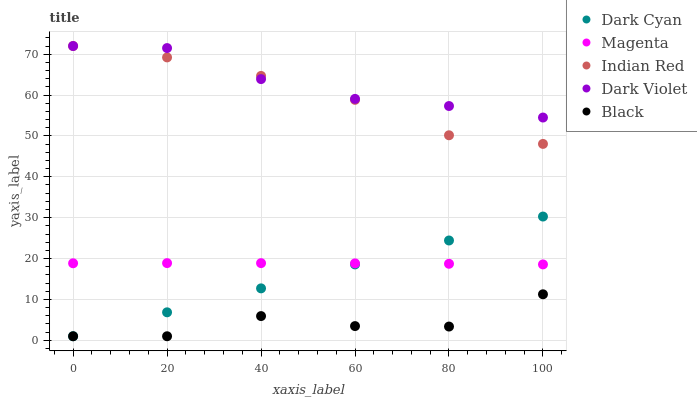Does Black have the minimum area under the curve?
Answer yes or no. Yes. Does Dark Violet have the maximum area under the curve?
Answer yes or no. Yes. Does Magenta have the minimum area under the curve?
Answer yes or no. No. Does Magenta have the maximum area under the curve?
Answer yes or no. No. Is Dark Cyan the smoothest?
Answer yes or no. Yes. Is Black the roughest?
Answer yes or no. Yes. Is Magenta the smoothest?
Answer yes or no. No. Is Magenta the roughest?
Answer yes or no. No. Does Dark Cyan have the lowest value?
Answer yes or no. Yes. Does Magenta have the lowest value?
Answer yes or no. No. Does Indian Red have the highest value?
Answer yes or no. Yes. Does Magenta have the highest value?
Answer yes or no. No. Is Dark Cyan less than Indian Red?
Answer yes or no. Yes. Is Indian Red greater than Black?
Answer yes or no. Yes. Does Indian Red intersect Dark Violet?
Answer yes or no. Yes. Is Indian Red less than Dark Violet?
Answer yes or no. No. Is Indian Red greater than Dark Violet?
Answer yes or no. No. Does Dark Cyan intersect Indian Red?
Answer yes or no. No. 